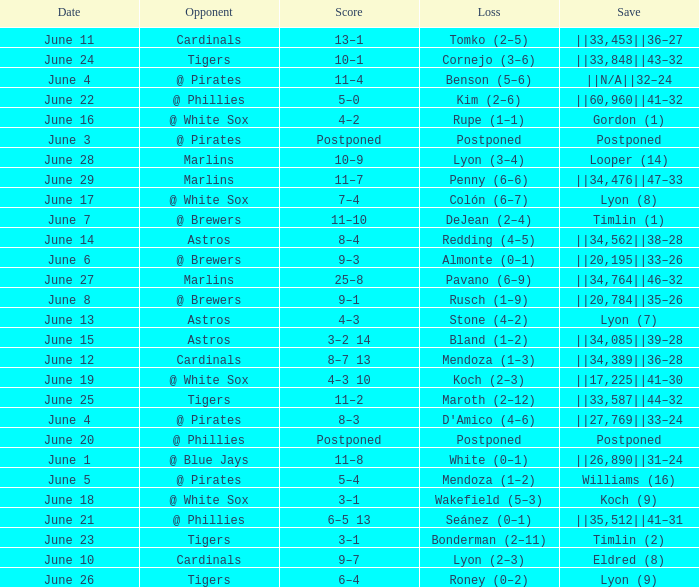Who is the opponent with a save of ||33,453||36–27? Cardinals. Would you mind parsing the complete table? {'header': ['Date', 'Opponent', 'Score', 'Loss', 'Save'], 'rows': [['June 11', 'Cardinals', '13–1', 'Tomko (2–5)', '||33,453||36–27'], ['June 24', 'Tigers', '10–1', 'Cornejo (3–6)', '||33,848||43–32'], ['June 4', '@ Pirates', '11–4', 'Benson (5–6)', '||N/A||32–24'], ['June 22', '@ Phillies', '5–0', 'Kim (2–6)', '||60,960||41–32'], ['June 16', '@ White Sox', '4–2', 'Rupe (1–1)', 'Gordon (1)'], ['June 3', '@ Pirates', 'Postponed', 'Postponed', 'Postponed'], ['June 28', 'Marlins', '10–9', 'Lyon (3–4)', 'Looper (14)'], ['June 29', 'Marlins', '11–7', 'Penny (6–6)', '||34,476||47–33'], ['June 17', '@ White Sox', '7–4', 'Colón (6–7)', 'Lyon (8)'], ['June 7', '@ Brewers', '11–10', 'DeJean (2–4)', 'Timlin (1)'], ['June 14', 'Astros', '8–4', 'Redding (4–5)', '||34,562||38–28'], ['June 6', '@ Brewers', '9–3', 'Almonte (0–1)', '||20,195||33–26'], ['June 27', 'Marlins', '25–8', 'Pavano (6–9)', '||34,764||46–32'], ['June 8', '@ Brewers', '9–1', 'Rusch (1–9)', '||20,784||35–26'], ['June 13', 'Astros', '4–3', 'Stone (4–2)', 'Lyon (7)'], ['June 15', 'Astros', '3–2 14', 'Bland (1–2)', '||34,085||39–28'], ['June 12', 'Cardinals', '8–7 13', 'Mendoza (1–3)', '||34,389||36–28'], ['June 19', '@ White Sox', '4–3 10', 'Koch (2–3)', '||17,225||41–30'], ['June 25', 'Tigers', '11–2', 'Maroth (2–12)', '||33,587||44–32'], ['June 4', '@ Pirates', '8–3', "D'Amico (4–6)", '||27,769||33–24'], ['June 20', '@ Phillies', 'Postponed', 'Postponed', 'Postponed'], ['June 1', '@ Blue Jays', '11–8', 'White (0–1)', '||26,890||31–24'], ['June 5', '@ Pirates', '5–4', 'Mendoza (1–2)', 'Williams (16)'], ['June 18', '@ White Sox', '3–1', 'Wakefield (5–3)', 'Koch (9)'], ['June 21', '@ Phillies', '6–5 13', 'Seánez (0–1)', '||35,512||41–31'], ['June 23', 'Tigers', '3–1', 'Bonderman (2–11)', 'Timlin (2)'], ['June 10', 'Cardinals', '9–7', 'Lyon (2–3)', 'Eldred (8)'], ['June 26', 'Tigers', '6–4', 'Roney (0–2)', 'Lyon (9)']]} 